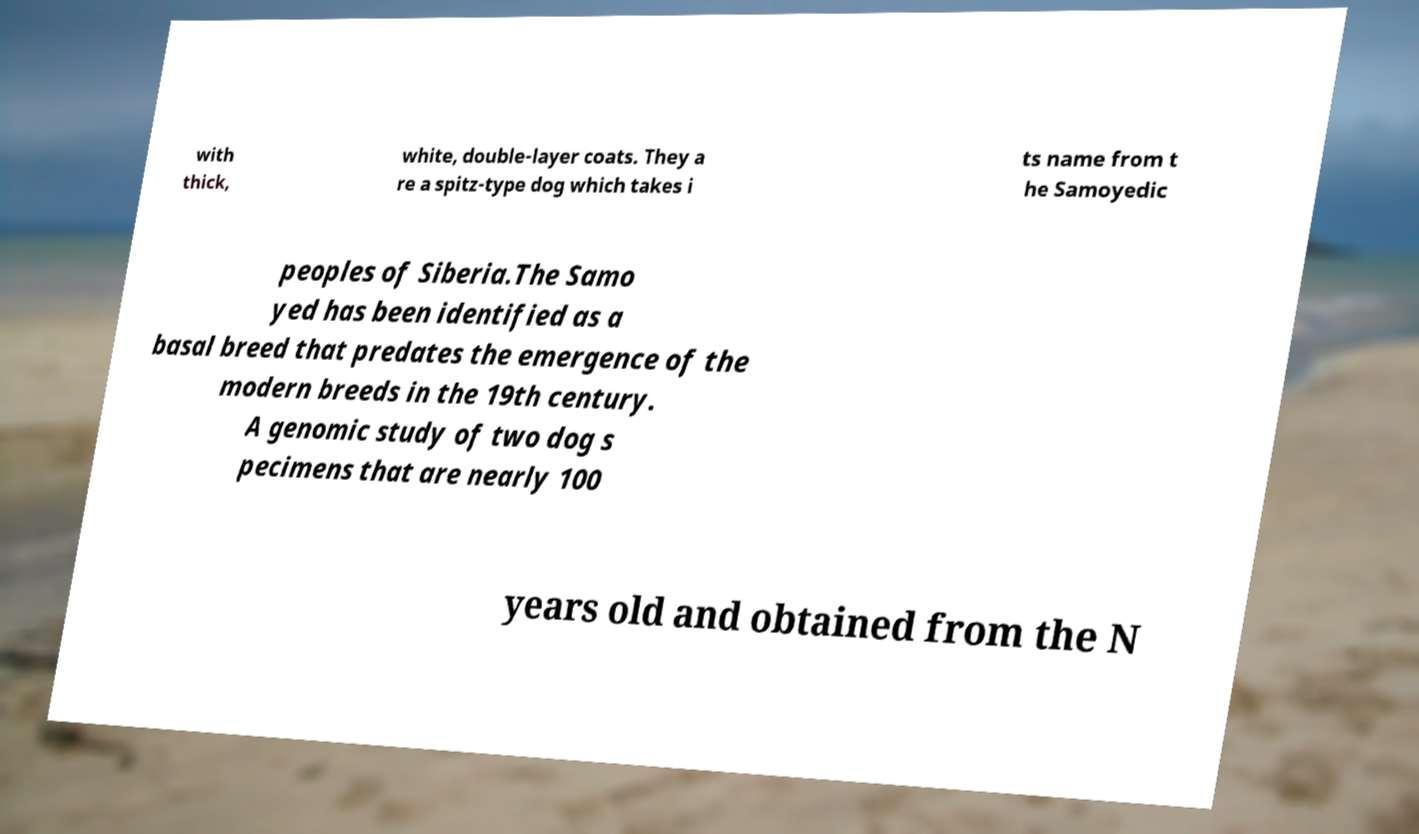Can you read and provide the text displayed in the image?This photo seems to have some interesting text. Can you extract and type it out for me? with thick, white, double-layer coats. They a re a spitz-type dog which takes i ts name from t he Samoyedic peoples of Siberia.The Samo yed has been identified as a basal breed that predates the emergence of the modern breeds in the 19th century. A genomic study of two dog s pecimens that are nearly 100 years old and obtained from the N 